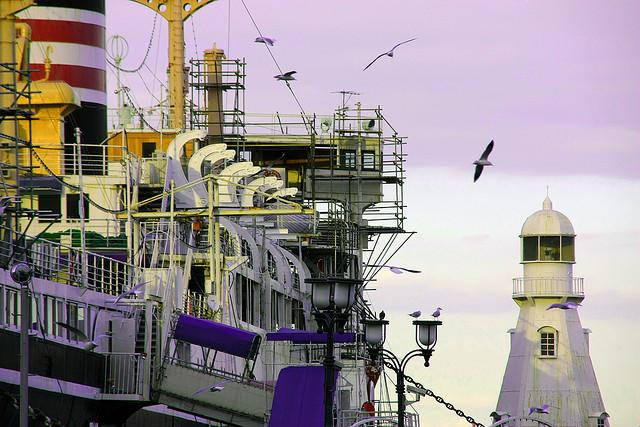How many kind of ships available mostly? one 